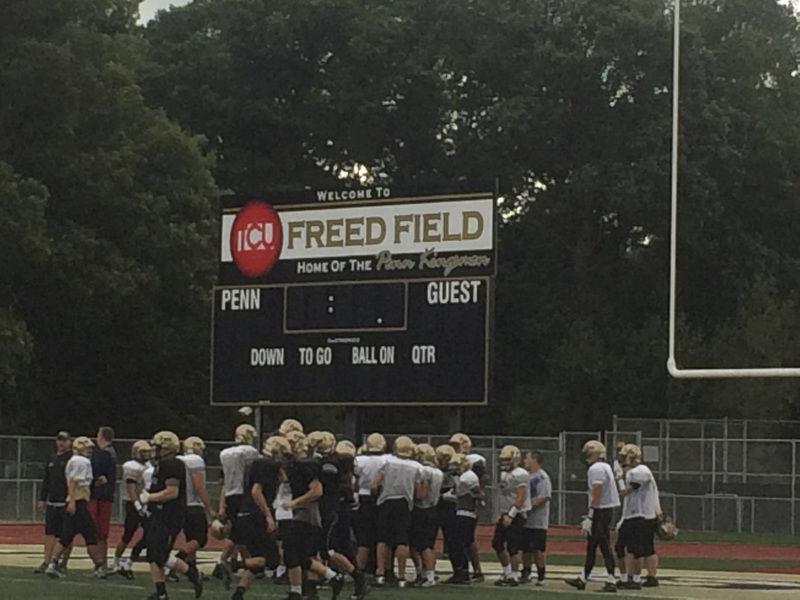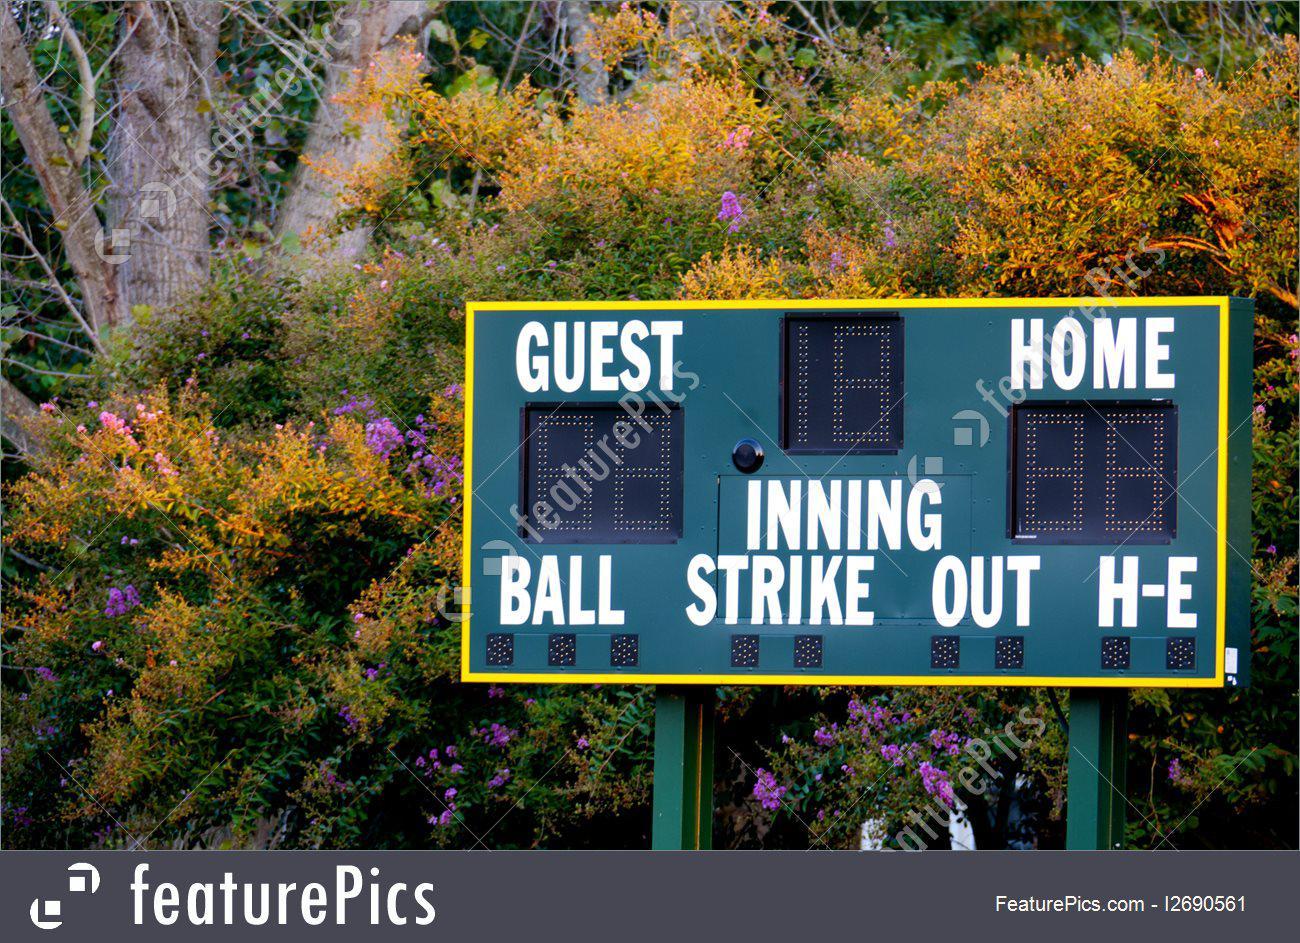The first image is the image on the left, the second image is the image on the right. Given the left and right images, does the statement "Twelve or more individual digits are illuminated in one of the images." hold true? Answer yes or no. No. The first image is the image on the left, the second image is the image on the right. Examine the images to the left and right. Is the description "One of the images shows a scoreboard with no people around and the other image shows a scoreboard with a team of players on the field." accurate? Answer yes or no. Yes. 